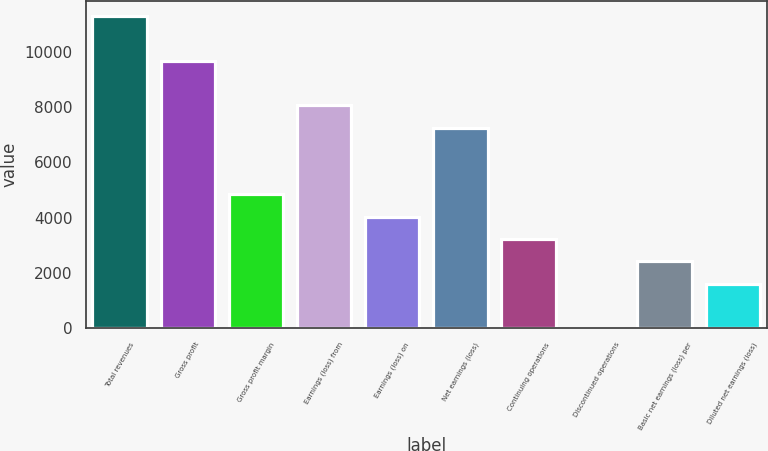Convert chart to OTSL. <chart><loc_0><loc_0><loc_500><loc_500><bar_chart><fcel>Total revenues<fcel>Gross profit<fcel>Gross profit margin<fcel>Earnings (loss) from<fcel>Earnings (loss) on<fcel>Net earnings (loss)<fcel>Continuing operations<fcel>Discontinued operations<fcel>Basic net earnings (loss) per<fcel>Diluted net earnings (loss)<nl><fcel>11286.7<fcel>9674.3<fcel>4837.16<fcel>8061.92<fcel>4030.97<fcel>7255.73<fcel>3224.78<fcel>0.02<fcel>2418.59<fcel>1612.4<nl></chart> 